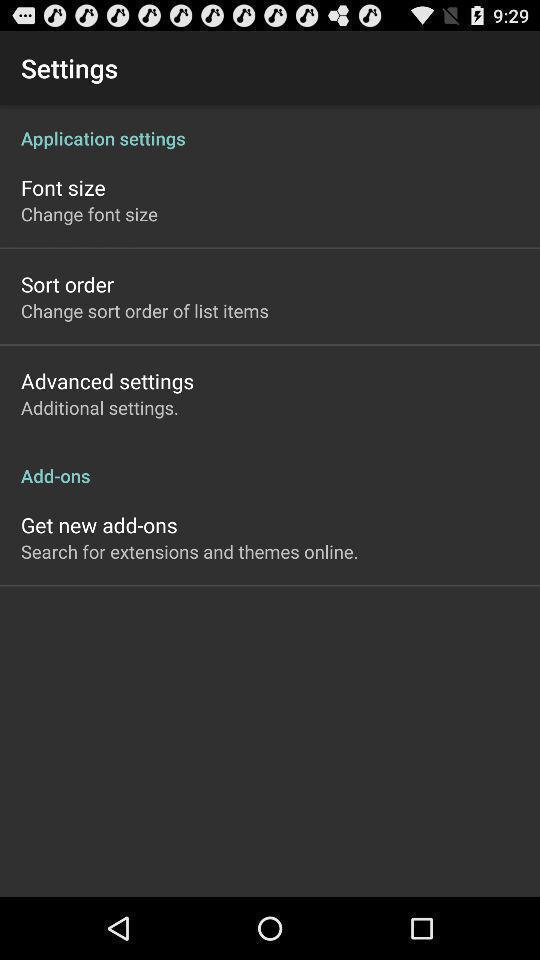Explain the elements present in this screenshot. Settings of shopping list app. 